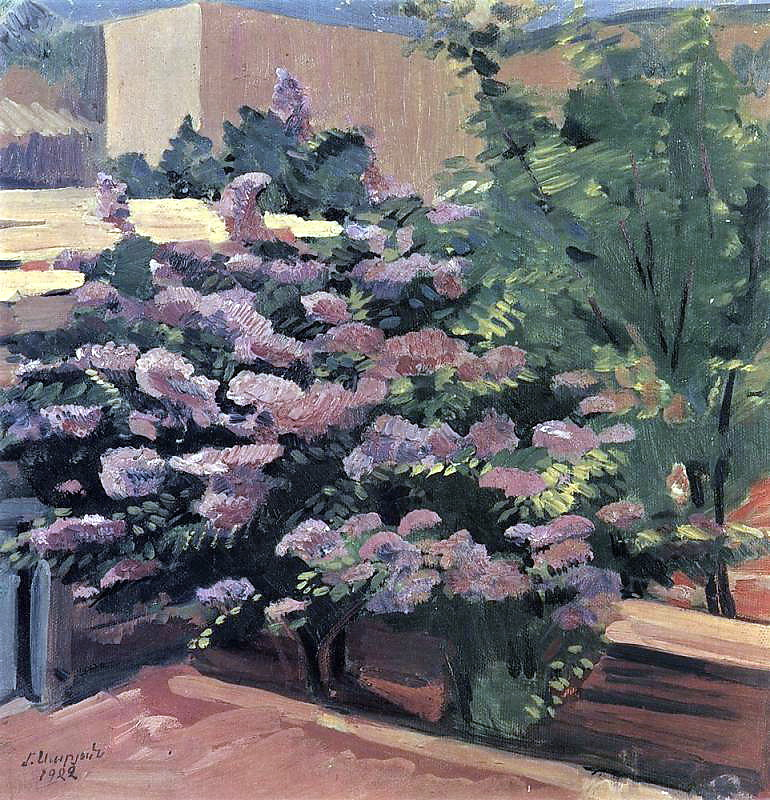Describe the mood this painting evokes. The painting evokes a mood of tranquility and serenity. The soft, harmonious colors and the delicate details of the flowers create a sense of calm and peacefulness. The depiction of a lush, blooming garden suggests a moment of quiet reflection and escape from the bustling world, inviting the viewer to immerse themselves in the beauty and stillness of nature. The hints of blue sky and the gentle play of light and shadow further enhance the feeling of contentment and relaxation, making it a perfect scene to unwind and find solace. In what ways might this garden change throughout the day? As the day progresses, the garden would undergo subtle changes, reflecting the shifting light and temperature. During the early morning, the flowers might be adorned with dew drops, glistening in the gentle morning light. The sunlight would be softer, casting long shadows and creating a cool, fresh ambiance. By midday, the sun would be high in the sky, bathing the garden in bright, warm light. The colors of the flowers and foliage would appear more vibrant, and the warmth might bring out the fragrant scents of the blooms. In the afternoon, the light would begin to soften again, creating a golden glow and casting different shadows as the sun moves lower. By evening, as the sun sets, the garden would be enveloped in a gentle twilight, with the colors taking on a more subdued, harmonious hue. The coolness of the evening air would begin to settle in, and nocturnal creatures like fireflies might start to appear, adding a different kind of magic to the scene. 